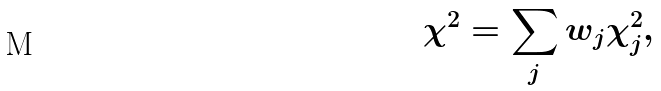<formula> <loc_0><loc_0><loc_500><loc_500>\chi ^ { 2 } = \sum _ { j } w _ { j } \chi _ { j } ^ { 2 } ,</formula> 